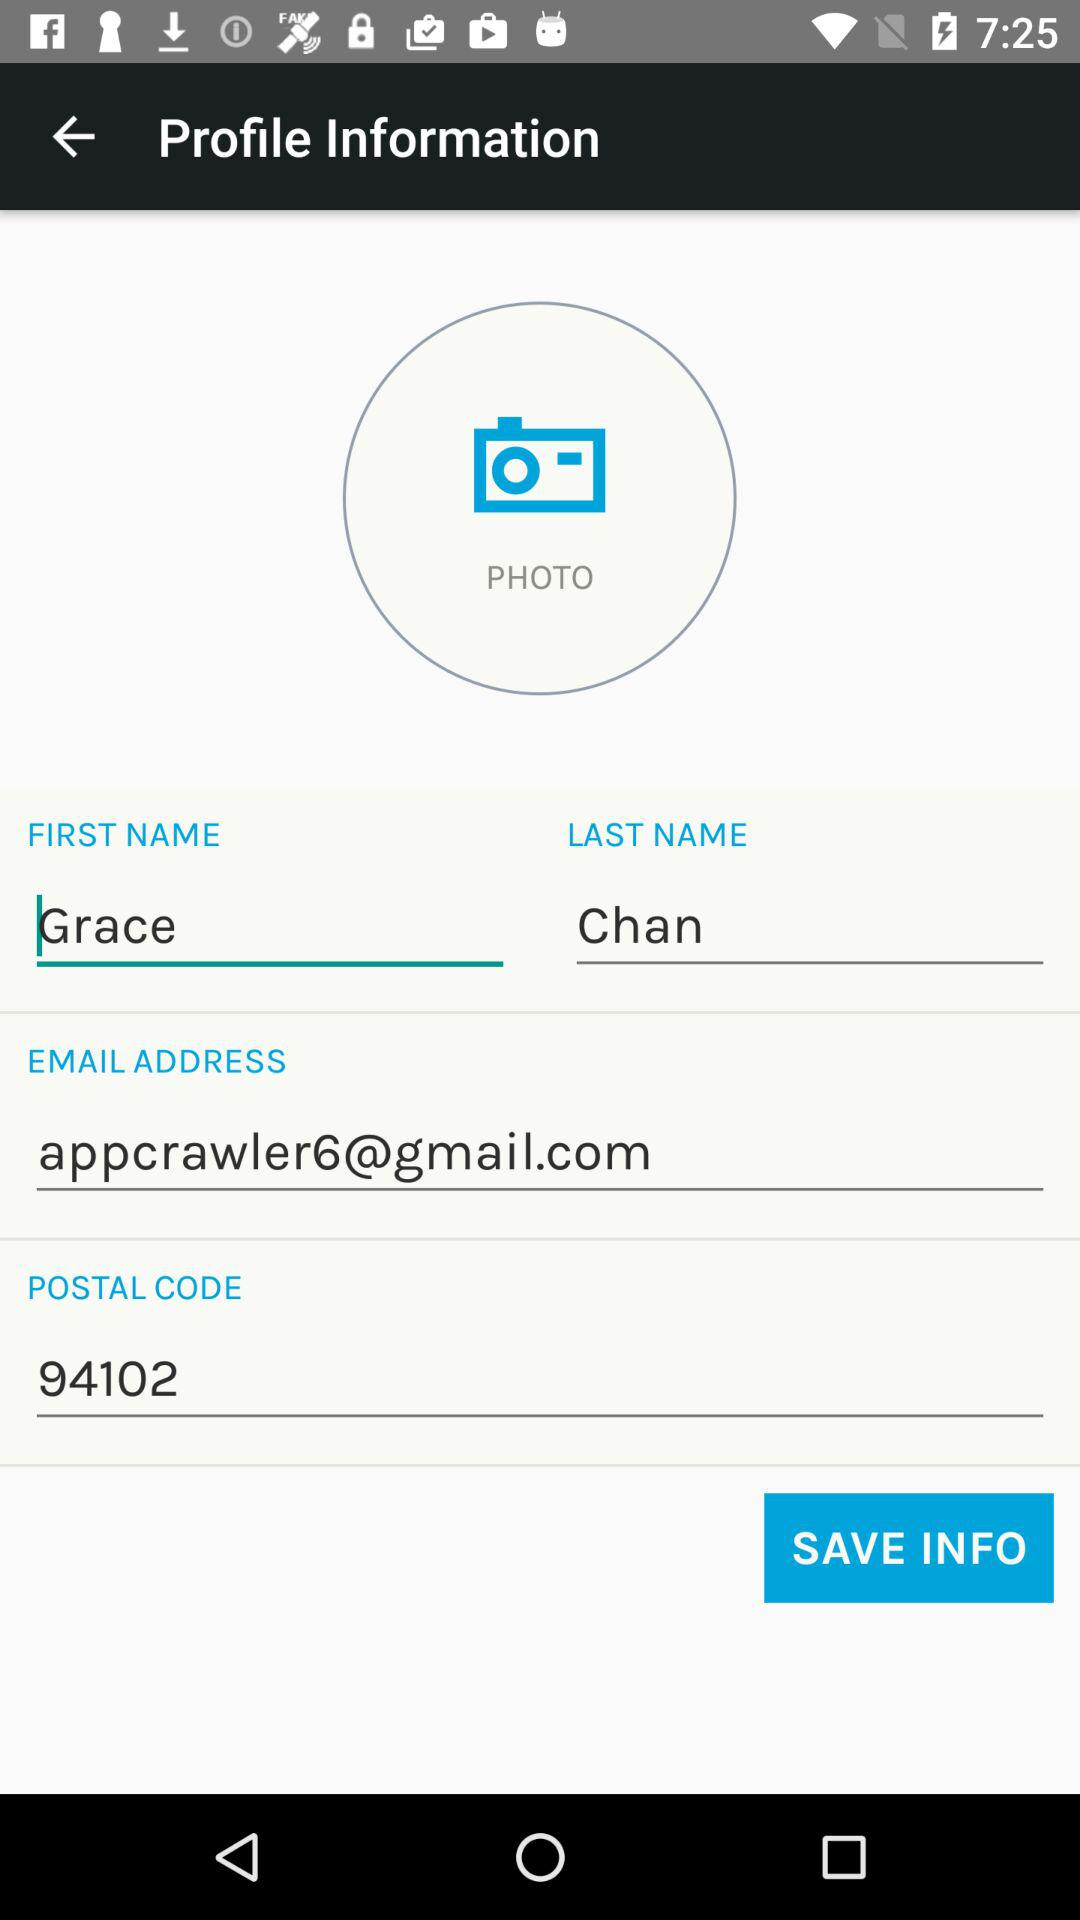What is the postal code? The postal code is 94102. 